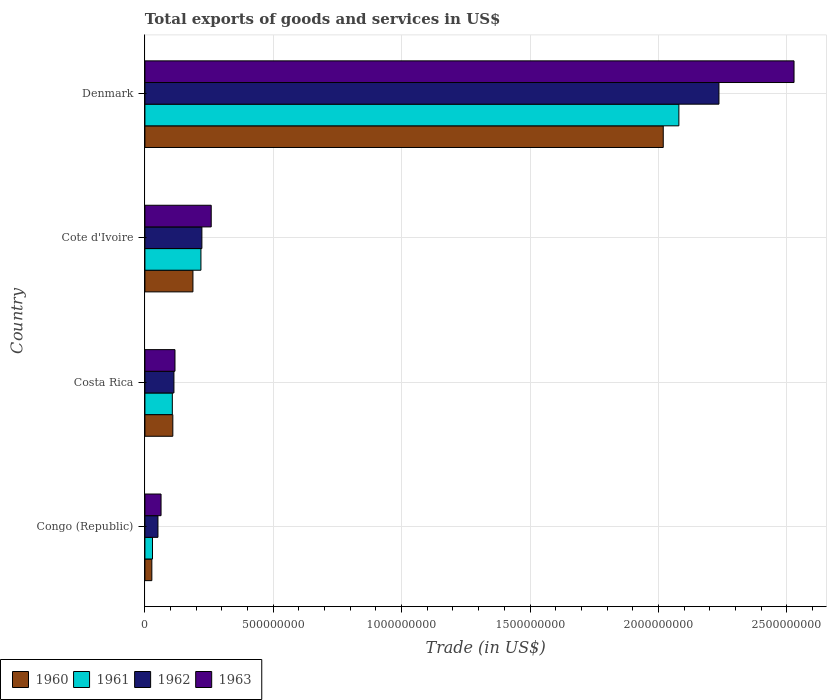Are the number of bars on each tick of the Y-axis equal?
Make the answer very short. Yes. How many bars are there on the 4th tick from the top?
Offer a very short reply. 4. How many bars are there on the 3rd tick from the bottom?
Offer a terse response. 4. What is the label of the 4th group of bars from the top?
Your answer should be very brief. Congo (Republic). What is the total exports of goods and services in 1962 in Congo (Republic)?
Offer a very short reply. 5.08e+07. Across all countries, what is the maximum total exports of goods and services in 1960?
Offer a very short reply. 2.02e+09. Across all countries, what is the minimum total exports of goods and services in 1960?
Keep it short and to the point. 2.69e+07. In which country was the total exports of goods and services in 1961 minimum?
Your answer should be compact. Congo (Republic). What is the total total exports of goods and services in 1962 in the graph?
Your answer should be very brief. 2.62e+09. What is the difference between the total exports of goods and services in 1962 in Congo (Republic) and that in Denmark?
Provide a succinct answer. -2.19e+09. What is the difference between the total exports of goods and services in 1962 in Cote d'Ivoire and the total exports of goods and services in 1960 in Denmark?
Your response must be concise. -1.80e+09. What is the average total exports of goods and services in 1961 per country?
Provide a short and direct response. 6.09e+08. What is the difference between the total exports of goods and services in 1963 and total exports of goods and services in 1961 in Costa Rica?
Your answer should be compact. 1.03e+07. In how many countries, is the total exports of goods and services in 1961 greater than 1300000000 US$?
Ensure brevity in your answer.  1. What is the ratio of the total exports of goods and services in 1962 in Costa Rica to that in Cote d'Ivoire?
Offer a terse response. 0.51. Is the total exports of goods and services in 1961 in Costa Rica less than that in Cote d'Ivoire?
Make the answer very short. Yes. Is the difference between the total exports of goods and services in 1963 in Congo (Republic) and Denmark greater than the difference between the total exports of goods and services in 1961 in Congo (Republic) and Denmark?
Give a very brief answer. No. What is the difference between the highest and the second highest total exports of goods and services in 1963?
Provide a short and direct response. 2.27e+09. What is the difference between the highest and the lowest total exports of goods and services in 1961?
Ensure brevity in your answer.  2.05e+09. In how many countries, is the total exports of goods and services in 1962 greater than the average total exports of goods and services in 1962 taken over all countries?
Provide a succinct answer. 1. Is the sum of the total exports of goods and services in 1961 in Costa Rica and Denmark greater than the maximum total exports of goods and services in 1962 across all countries?
Provide a short and direct response. No. Is it the case that in every country, the sum of the total exports of goods and services in 1963 and total exports of goods and services in 1961 is greater than the sum of total exports of goods and services in 1962 and total exports of goods and services in 1960?
Make the answer very short. No. What does the 1st bar from the bottom in Cote d'Ivoire represents?
Make the answer very short. 1960. Is it the case that in every country, the sum of the total exports of goods and services in 1962 and total exports of goods and services in 1960 is greater than the total exports of goods and services in 1963?
Provide a short and direct response. Yes. Does the graph contain any zero values?
Provide a succinct answer. No. Where does the legend appear in the graph?
Your response must be concise. Bottom left. How are the legend labels stacked?
Offer a terse response. Horizontal. What is the title of the graph?
Your answer should be compact. Total exports of goods and services in US$. What is the label or title of the X-axis?
Offer a terse response. Trade (in US$). What is the Trade (in US$) of 1960 in Congo (Republic)?
Ensure brevity in your answer.  2.69e+07. What is the Trade (in US$) of 1961 in Congo (Republic)?
Ensure brevity in your answer.  2.95e+07. What is the Trade (in US$) of 1962 in Congo (Republic)?
Your answer should be compact. 5.08e+07. What is the Trade (in US$) of 1963 in Congo (Republic)?
Your answer should be compact. 6.28e+07. What is the Trade (in US$) of 1960 in Costa Rica?
Offer a very short reply. 1.09e+08. What is the Trade (in US$) in 1961 in Costa Rica?
Offer a very short reply. 1.07e+08. What is the Trade (in US$) of 1962 in Costa Rica?
Give a very brief answer. 1.13e+08. What is the Trade (in US$) of 1963 in Costa Rica?
Provide a short and direct response. 1.17e+08. What is the Trade (in US$) of 1960 in Cote d'Ivoire?
Give a very brief answer. 1.87e+08. What is the Trade (in US$) of 1961 in Cote d'Ivoire?
Keep it short and to the point. 2.18e+08. What is the Trade (in US$) of 1962 in Cote d'Ivoire?
Offer a terse response. 2.22e+08. What is the Trade (in US$) in 1963 in Cote d'Ivoire?
Make the answer very short. 2.58e+08. What is the Trade (in US$) of 1960 in Denmark?
Offer a very short reply. 2.02e+09. What is the Trade (in US$) in 1961 in Denmark?
Make the answer very short. 2.08e+09. What is the Trade (in US$) of 1962 in Denmark?
Offer a very short reply. 2.24e+09. What is the Trade (in US$) in 1963 in Denmark?
Your answer should be very brief. 2.53e+09. Across all countries, what is the maximum Trade (in US$) in 1960?
Give a very brief answer. 2.02e+09. Across all countries, what is the maximum Trade (in US$) of 1961?
Give a very brief answer. 2.08e+09. Across all countries, what is the maximum Trade (in US$) of 1962?
Your answer should be very brief. 2.24e+09. Across all countries, what is the maximum Trade (in US$) of 1963?
Your answer should be compact. 2.53e+09. Across all countries, what is the minimum Trade (in US$) in 1960?
Your answer should be very brief. 2.69e+07. Across all countries, what is the minimum Trade (in US$) in 1961?
Offer a terse response. 2.95e+07. Across all countries, what is the minimum Trade (in US$) in 1962?
Make the answer very short. 5.08e+07. Across all countries, what is the minimum Trade (in US$) in 1963?
Your answer should be compact. 6.28e+07. What is the total Trade (in US$) of 1960 in the graph?
Offer a terse response. 2.34e+09. What is the total Trade (in US$) of 1961 in the graph?
Offer a very short reply. 2.43e+09. What is the total Trade (in US$) of 1962 in the graph?
Your answer should be very brief. 2.62e+09. What is the total Trade (in US$) in 1963 in the graph?
Keep it short and to the point. 2.97e+09. What is the difference between the Trade (in US$) in 1960 in Congo (Republic) and that in Costa Rica?
Give a very brief answer. -8.17e+07. What is the difference between the Trade (in US$) in 1961 in Congo (Republic) and that in Costa Rica?
Offer a terse response. -7.73e+07. What is the difference between the Trade (in US$) in 1962 in Congo (Republic) and that in Costa Rica?
Provide a succinct answer. -6.23e+07. What is the difference between the Trade (in US$) in 1963 in Congo (Republic) and that in Costa Rica?
Ensure brevity in your answer.  -5.43e+07. What is the difference between the Trade (in US$) of 1960 in Congo (Republic) and that in Cote d'Ivoire?
Your response must be concise. -1.60e+08. What is the difference between the Trade (in US$) of 1961 in Congo (Republic) and that in Cote d'Ivoire?
Your answer should be compact. -1.89e+08. What is the difference between the Trade (in US$) of 1962 in Congo (Republic) and that in Cote d'Ivoire?
Your answer should be compact. -1.71e+08. What is the difference between the Trade (in US$) in 1963 in Congo (Republic) and that in Cote d'Ivoire?
Ensure brevity in your answer.  -1.95e+08. What is the difference between the Trade (in US$) of 1960 in Congo (Republic) and that in Denmark?
Offer a terse response. -1.99e+09. What is the difference between the Trade (in US$) of 1961 in Congo (Republic) and that in Denmark?
Keep it short and to the point. -2.05e+09. What is the difference between the Trade (in US$) of 1962 in Congo (Republic) and that in Denmark?
Offer a terse response. -2.19e+09. What is the difference between the Trade (in US$) of 1963 in Congo (Republic) and that in Denmark?
Make the answer very short. -2.47e+09. What is the difference between the Trade (in US$) of 1960 in Costa Rica and that in Cote d'Ivoire?
Your answer should be compact. -7.83e+07. What is the difference between the Trade (in US$) of 1961 in Costa Rica and that in Cote d'Ivoire?
Your response must be concise. -1.11e+08. What is the difference between the Trade (in US$) of 1962 in Costa Rica and that in Cote d'Ivoire?
Give a very brief answer. -1.09e+08. What is the difference between the Trade (in US$) of 1963 in Costa Rica and that in Cote d'Ivoire?
Keep it short and to the point. -1.41e+08. What is the difference between the Trade (in US$) of 1960 in Costa Rica and that in Denmark?
Ensure brevity in your answer.  -1.91e+09. What is the difference between the Trade (in US$) in 1961 in Costa Rica and that in Denmark?
Ensure brevity in your answer.  -1.97e+09. What is the difference between the Trade (in US$) in 1962 in Costa Rica and that in Denmark?
Your response must be concise. -2.12e+09. What is the difference between the Trade (in US$) in 1963 in Costa Rica and that in Denmark?
Your answer should be very brief. -2.41e+09. What is the difference between the Trade (in US$) in 1960 in Cote d'Ivoire and that in Denmark?
Offer a very short reply. -1.83e+09. What is the difference between the Trade (in US$) of 1961 in Cote d'Ivoire and that in Denmark?
Your response must be concise. -1.86e+09. What is the difference between the Trade (in US$) in 1962 in Cote d'Ivoire and that in Denmark?
Your answer should be very brief. -2.01e+09. What is the difference between the Trade (in US$) of 1963 in Cote d'Ivoire and that in Denmark?
Provide a succinct answer. -2.27e+09. What is the difference between the Trade (in US$) of 1960 in Congo (Republic) and the Trade (in US$) of 1961 in Costa Rica?
Give a very brief answer. -7.98e+07. What is the difference between the Trade (in US$) of 1960 in Congo (Republic) and the Trade (in US$) of 1962 in Costa Rica?
Offer a very short reply. -8.61e+07. What is the difference between the Trade (in US$) of 1960 in Congo (Republic) and the Trade (in US$) of 1963 in Costa Rica?
Provide a succinct answer. -9.02e+07. What is the difference between the Trade (in US$) of 1961 in Congo (Republic) and the Trade (in US$) of 1962 in Costa Rica?
Keep it short and to the point. -8.35e+07. What is the difference between the Trade (in US$) of 1961 in Congo (Republic) and the Trade (in US$) of 1963 in Costa Rica?
Your answer should be very brief. -8.76e+07. What is the difference between the Trade (in US$) in 1962 in Congo (Republic) and the Trade (in US$) in 1963 in Costa Rica?
Keep it short and to the point. -6.63e+07. What is the difference between the Trade (in US$) in 1960 in Congo (Republic) and the Trade (in US$) in 1961 in Cote d'Ivoire?
Keep it short and to the point. -1.91e+08. What is the difference between the Trade (in US$) in 1960 in Congo (Republic) and the Trade (in US$) in 1962 in Cote d'Ivoire?
Ensure brevity in your answer.  -1.95e+08. What is the difference between the Trade (in US$) of 1960 in Congo (Republic) and the Trade (in US$) of 1963 in Cote d'Ivoire?
Offer a terse response. -2.31e+08. What is the difference between the Trade (in US$) of 1961 in Congo (Republic) and the Trade (in US$) of 1962 in Cote d'Ivoire?
Make the answer very short. -1.92e+08. What is the difference between the Trade (in US$) in 1961 in Congo (Republic) and the Trade (in US$) in 1963 in Cote d'Ivoire?
Give a very brief answer. -2.29e+08. What is the difference between the Trade (in US$) of 1962 in Congo (Republic) and the Trade (in US$) of 1963 in Cote d'Ivoire?
Your answer should be very brief. -2.07e+08. What is the difference between the Trade (in US$) in 1960 in Congo (Republic) and the Trade (in US$) in 1961 in Denmark?
Keep it short and to the point. -2.05e+09. What is the difference between the Trade (in US$) of 1960 in Congo (Republic) and the Trade (in US$) of 1962 in Denmark?
Ensure brevity in your answer.  -2.21e+09. What is the difference between the Trade (in US$) of 1960 in Congo (Republic) and the Trade (in US$) of 1963 in Denmark?
Offer a terse response. -2.50e+09. What is the difference between the Trade (in US$) of 1961 in Congo (Republic) and the Trade (in US$) of 1962 in Denmark?
Your answer should be very brief. -2.21e+09. What is the difference between the Trade (in US$) in 1961 in Congo (Republic) and the Trade (in US$) in 1963 in Denmark?
Give a very brief answer. -2.50e+09. What is the difference between the Trade (in US$) of 1962 in Congo (Republic) and the Trade (in US$) of 1963 in Denmark?
Your response must be concise. -2.48e+09. What is the difference between the Trade (in US$) in 1960 in Costa Rica and the Trade (in US$) in 1961 in Cote d'Ivoire?
Offer a terse response. -1.10e+08. What is the difference between the Trade (in US$) of 1960 in Costa Rica and the Trade (in US$) of 1962 in Cote d'Ivoire?
Make the answer very short. -1.13e+08. What is the difference between the Trade (in US$) in 1960 in Costa Rica and the Trade (in US$) in 1963 in Cote d'Ivoire?
Your answer should be very brief. -1.50e+08. What is the difference between the Trade (in US$) in 1961 in Costa Rica and the Trade (in US$) in 1962 in Cote d'Ivoire?
Ensure brevity in your answer.  -1.15e+08. What is the difference between the Trade (in US$) in 1961 in Costa Rica and the Trade (in US$) in 1963 in Cote d'Ivoire?
Your answer should be very brief. -1.51e+08. What is the difference between the Trade (in US$) in 1962 in Costa Rica and the Trade (in US$) in 1963 in Cote d'Ivoire?
Your answer should be very brief. -1.45e+08. What is the difference between the Trade (in US$) in 1960 in Costa Rica and the Trade (in US$) in 1961 in Denmark?
Offer a very short reply. -1.97e+09. What is the difference between the Trade (in US$) of 1960 in Costa Rica and the Trade (in US$) of 1962 in Denmark?
Your answer should be compact. -2.13e+09. What is the difference between the Trade (in US$) of 1960 in Costa Rica and the Trade (in US$) of 1963 in Denmark?
Provide a succinct answer. -2.42e+09. What is the difference between the Trade (in US$) of 1961 in Costa Rica and the Trade (in US$) of 1962 in Denmark?
Offer a terse response. -2.13e+09. What is the difference between the Trade (in US$) of 1961 in Costa Rica and the Trade (in US$) of 1963 in Denmark?
Provide a succinct answer. -2.42e+09. What is the difference between the Trade (in US$) of 1962 in Costa Rica and the Trade (in US$) of 1963 in Denmark?
Your answer should be very brief. -2.42e+09. What is the difference between the Trade (in US$) of 1960 in Cote d'Ivoire and the Trade (in US$) of 1961 in Denmark?
Your answer should be compact. -1.89e+09. What is the difference between the Trade (in US$) in 1960 in Cote d'Ivoire and the Trade (in US$) in 1962 in Denmark?
Your response must be concise. -2.05e+09. What is the difference between the Trade (in US$) in 1960 in Cote d'Ivoire and the Trade (in US$) in 1963 in Denmark?
Make the answer very short. -2.34e+09. What is the difference between the Trade (in US$) in 1961 in Cote d'Ivoire and the Trade (in US$) in 1962 in Denmark?
Make the answer very short. -2.02e+09. What is the difference between the Trade (in US$) in 1961 in Cote d'Ivoire and the Trade (in US$) in 1963 in Denmark?
Give a very brief answer. -2.31e+09. What is the difference between the Trade (in US$) in 1962 in Cote d'Ivoire and the Trade (in US$) in 1963 in Denmark?
Your answer should be very brief. -2.31e+09. What is the average Trade (in US$) of 1960 per country?
Provide a short and direct response. 5.85e+08. What is the average Trade (in US$) of 1961 per country?
Your answer should be compact. 6.09e+08. What is the average Trade (in US$) of 1962 per country?
Your response must be concise. 6.55e+08. What is the average Trade (in US$) in 1963 per country?
Give a very brief answer. 7.42e+08. What is the difference between the Trade (in US$) of 1960 and Trade (in US$) of 1961 in Congo (Republic)?
Keep it short and to the point. -2.57e+06. What is the difference between the Trade (in US$) in 1960 and Trade (in US$) in 1962 in Congo (Republic)?
Your answer should be very brief. -2.38e+07. What is the difference between the Trade (in US$) in 1960 and Trade (in US$) in 1963 in Congo (Republic)?
Provide a succinct answer. -3.59e+07. What is the difference between the Trade (in US$) in 1961 and Trade (in US$) in 1962 in Congo (Republic)?
Provide a succinct answer. -2.13e+07. What is the difference between the Trade (in US$) in 1961 and Trade (in US$) in 1963 in Congo (Republic)?
Provide a succinct answer. -3.33e+07. What is the difference between the Trade (in US$) in 1962 and Trade (in US$) in 1963 in Congo (Republic)?
Your response must be concise. -1.20e+07. What is the difference between the Trade (in US$) of 1960 and Trade (in US$) of 1961 in Costa Rica?
Your answer should be very brief. 1.90e+06. What is the difference between the Trade (in US$) of 1960 and Trade (in US$) of 1962 in Costa Rica?
Your answer should be compact. -4.35e+06. What is the difference between the Trade (in US$) of 1960 and Trade (in US$) of 1963 in Costa Rica?
Give a very brief answer. -8.42e+06. What is the difference between the Trade (in US$) of 1961 and Trade (in US$) of 1962 in Costa Rica?
Ensure brevity in your answer.  -6.24e+06. What is the difference between the Trade (in US$) in 1961 and Trade (in US$) in 1963 in Costa Rica?
Provide a succinct answer. -1.03e+07. What is the difference between the Trade (in US$) of 1962 and Trade (in US$) of 1963 in Costa Rica?
Offer a very short reply. -4.08e+06. What is the difference between the Trade (in US$) in 1960 and Trade (in US$) in 1961 in Cote d'Ivoire?
Offer a terse response. -3.12e+07. What is the difference between the Trade (in US$) in 1960 and Trade (in US$) in 1962 in Cote d'Ivoire?
Offer a terse response. -3.49e+07. What is the difference between the Trade (in US$) in 1960 and Trade (in US$) in 1963 in Cote d'Ivoire?
Your answer should be compact. -7.12e+07. What is the difference between the Trade (in US$) in 1961 and Trade (in US$) in 1962 in Cote d'Ivoire?
Provide a succinct answer. -3.74e+06. What is the difference between the Trade (in US$) in 1961 and Trade (in US$) in 1963 in Cote d'Ivoire?
Your response must be concise. -4.01e+07. What is the difference between the Trade (in US$) of 1962 and Trade (in US$) of 1963 in Cote d'Ivoire?
Your answer should be very brief. -3.63e+07. What is the difference between the Trade (in US$) of 1960 and Trade (in US$) of 1961 in Denmark?
Keep it short and to the point. -6.09e+07. What is the difference between the Trade (in US$) in 1960 and Trade (in US$) in 1962 in Denmark?
Offer a terse response. -2.17e+08. What is the difference between the Trade (in US$) of 1960 and Trade (in US$) of 1963 in Denmark?
Your response must be concise. -5.09e+08. What is the difference between the Trade (in US$) in 1961 and Trade (in US$) in 1962 in Denmark?
Provide a succinct answer. -1.56e+08. What is the difference between the Trade (in US$) of 1961 and Trade (in US$) of 1963 in Denmark?
Keep it short and to the point. -4.49e+08. What is the difference between the Trade (in US$) of 1962 and Trade (in US$) of 1963 in Denmark?
Ensure brevity in your answer.  -2.92e+08. What is the ratio of the Trade (in US$) of 1960 in Congo (Republic) to that in Costa Rica?
Your response must be concise. 0.25. What is the ratio of the Trade (in US$) of 1961 in Congo (Republic) to that in Costa Rica?
Provide a short and direct response. 0.28. What is the ratio of the Trade (in US$) in 1962 in Congo (Republic) to that in Costa Rica?
Provide a short and direct response. 0.45. What is the ratio of the Trade (in US$) of 1963 in Congo (Republic) to that in Costa Rica?
Your answer should be very brief. 0.54. What is the ratio of the Trade (in US$) of 1960 in Congo (Republic) to that in Cote d'Ivoire?
Provide a short and direct response. 0.14. What is the ratio of the Trade (in US$) of 1961 in Congo (Republic) to that in Cote d'Ivoire?
Provide a short and direct response. 0.14. What is the ratio of the Trade (in US$) in 1962 in Congo (Republic) to that in Cote d'Ivoire?
Your answer should be compact. 0.23. What is the ratio of the Trade (in US$) of 1963 in Congo (Republic) to that in Cote d'Ivoire?
Keep it short and to the point. 0.24. What is the ratio of the Trade (in US$) in 1960 in Congo (Republic) to that in Denmark?
Your response must be concise. 0.01. What is the ratio of the Trade (in US$) in 1961 in Congo (Republic) to that in Denmark?
Make the answer very short. 0.01. What is the ratio of the Trade (in US$) in 1962 in Congo (Republic) to that in Denmark?
Provide a short and direct response. 0.02. What is the ratio of the Trade (in US$) of 1963 in Congo (Republic) to that in Denmark?
Provide a short and direct response. 0.02. What is the ratio of the Trade (in US$) of 1960 in Costa Rica to that in Cote d'Ivoire?
Offer a very short reply. 0.58. What is the ratio of the Trade (in US$) of 1961 in Costa Rica to that in Cote d'Ivoire?
Your answer should be compact. 0.49. What is the ratio of the Trade (in US$) of 1962 in Costa Rica to that in Cote d'Ivoire?
Provide a succinct answer. 0.51. What is the ratio of the Trade (in US$) of 1963 in Costa Rica to that in Cote d'Ivoire?
Your answer should be very brief. 0.45. What is the ratio of the Trade (in US$) in 1960 in Costa Rica to that in Denmark?
Your answer should be compact. 0.05. What is the ratio of the Trade (in US$) in 1961 in Costa Rica to that in Denmark?
Your answer should be compact. 0.05. What is the ratio of the Trade (in US$) in 1962 in Costa Rica to that in Denmark?
Provide a succinct answer. 0.05. What is the ratio of the Trade (in US$) in 1963 in Costa Rica to that in Denmark?
Make the answer very short. 0.05. What is the ratio of the Trade (in US$) of 1960 in Cote d'Ivoire to that in Denmark?
Provide a succinct answer. 0.09. What is the ratio of the Trade (in US$) in 1961 in Cote d'Ivoire to that in Denmark?
Ensure brevity in your answer.  0.1. What is the ratio of the Trade (in US$) of 1962 in Cote d'Ivoire to that in Denmark?
Make the answer very short. 0.1. What is the ratio of the Trade (in US$) in 1963 in Cote d'Ivoire to that in Denmark?
Keep it short and to the point. 0.1. What is the difference between the highest and the second highest Trade (in US$) in 1960?
Offer a very short reply. 1.83e+09. What is the difference between the highest and the second highest Trade (in US$) in 1961?
Provide a short and direct response. 1.86e+09. What is the difference between the highest and the second highest Trade (in US$) of 1962?
Provide a succinct answer. 2.01e+09. What is the difference between the highest and the second highest Trade (in US$) in 1963?
Offer a terse response. 2.27e+09. What is the difference between the highest and the lowest Trade (in US$) in 1960?
Give a very brief answer. 1.99e+09. What is the difference between the highest and the lowest Trade (in US$) in 1961?
Offer a terse response. 2.05e+09. What is the difference between the highest and the lowest Trade (in US$) of 1962?
Give a very brief answer. 2.19e+09. What is the difference between the highest and the lowest Trade (in US$) in 1963?
Your answer should be compact. 2.47e+09. 